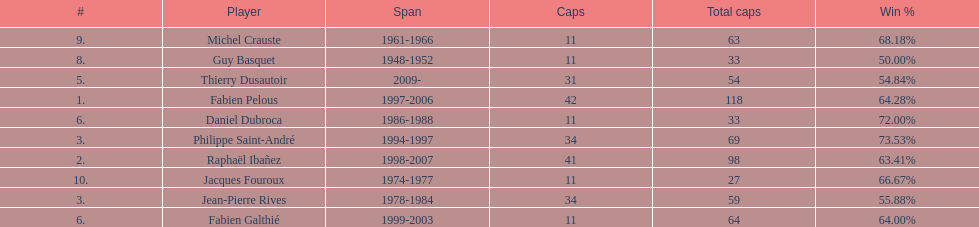How many caps did guy basquet accrue during his career? 33. 